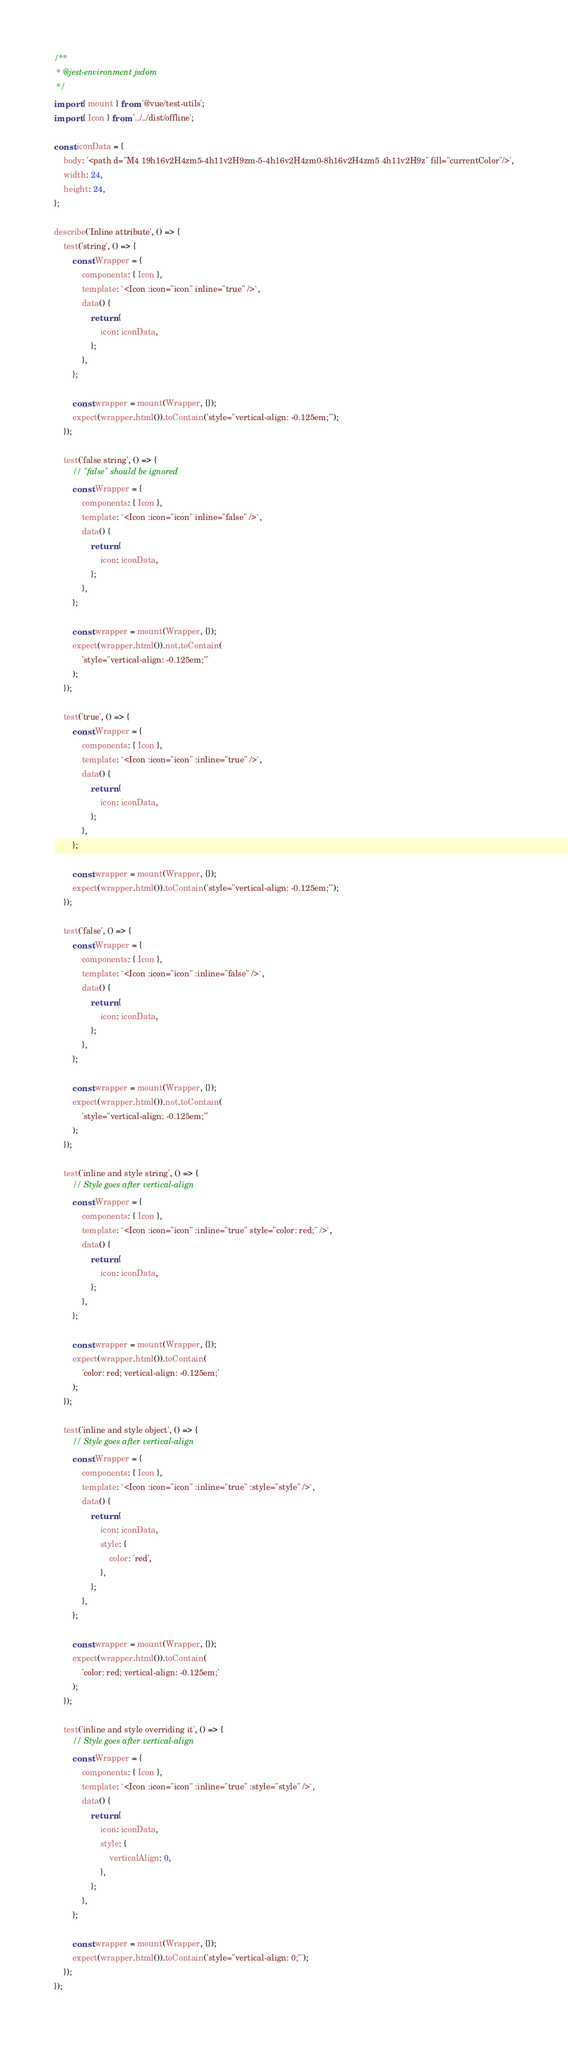<code> <loc_0><loc_0><loc_500><loc_500><_JavaScript_>/**
 * @jest-environment jsdom
 */
import { mount } from '@vue/test-utils';
import { Icon } from '../../dist/offline';

const iconData = {
	body: '<path d="M4 19h16v2H4zm5-4h11v2H9zm-5-4h16v2H4zm0-8h16v2H4zm5 4h11v2H9z" fill="currentColor"/>',
	width: 24,
	height: 24,
};

describe('Inline attribute', () => {
	test('string', () => {
		const Wrapper = {
			components: { Icon },
			template: `<Icon :icon="icon" inline="true" />`,
			data() {
				return {
					icon: iconData,
				};
			},
		};

		const wrapper = mount(Wrapper, {});
		expect(wrapper.html()).toContain('style="vertical-align: -0.125em;"');
	});

	test('false string', () => {
		// "false" should be ignored
		const Wrapper = {
			components: { Icon },
			template: `<Icon :icon="icon" inline="false" />`,
			data() {
				return {
					icon: iconData,
				};
			},
		};

		const wrapper = mount(Wrapper, {});
		expect(wrapper.html()).not.toContain(
			'style="vertical-align: -0.125em;"'
		);
	});

	test('true', () => {
		const Wrapper = {
			components: { Icon },
			template: `<Icon :icon="icon" :inline="true" />`,
			data() {
				return {
					icon: iconData,
				};
			},
		};

		const wrapper = mount(Wrapper, {});
		expect(wrapper.html()).toContain('style="vertical-align: -0.125em;"');
	});

	test('false', () => {
		const Wrapper = {
			components: { Icon },
			template: `<Icon :icon="icon" :inline="false" />`,
			data() {
				return {
					icon: iconData,
				};
			},
		};

		const wrapper = mount(Wrapper, {});
		expect(wrapper.html()).not.toContain(
			'style="vertical-align: -0.125em;"'
		);
	});

	test('inline and style string', () => {
		// Style goes after vertical-align
		const Wrapper = {
			components: { Icon },
			template: `<Icon :icon="icon" :inline="true" style="color: red;" />`,
			data() {
				return {
					icon: iconData,
				};
			},
		};

		const wrapper = mount(Wrapper, {});
		expect(wrapper.html()).toContain(
			'color: red; vertical-align: -0.125em;'
		);
	});

	test('inline and style object', () => {
		// Style goes after vertical-align
		const Wrapper = {
			components: { Icon },
			template: `<Icon :icon="icon" :inline="true" :style="style" />`,
			data() {
				return {
					icon: iconData,
					style: {
						color: 'red',
					},
				};
			},
		};

		const wrapper = mount(Wrapper, {});
		expect(wrapper.html()).toContain(
			'color: red; vertical-align: -0.125em;'
		);
	});

	test('inline and style overriding it', () => {
		// Style goes after vertical-align
		const Wrapper = {
			components: { Icon },
			template: `<Icon :icon="icon" :inline="true" :style="style" />`,
			data() {
				return {
					icon: iconData,
					style: {
						verticalAlign: 0,
					},
				};
			},
		};

		const wrapper = mount(Wrapper, {});
		expect(wrapper.html()).toContain('style="vertical-align: 0;"');
	});
});
</code> 